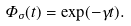Convert formula to latex. <formula><loc_0><loc_0><loc_500><loc_500>\Phi _ { \sigma } ( t ) = \exp ( - \gamma t ) .</formula> 